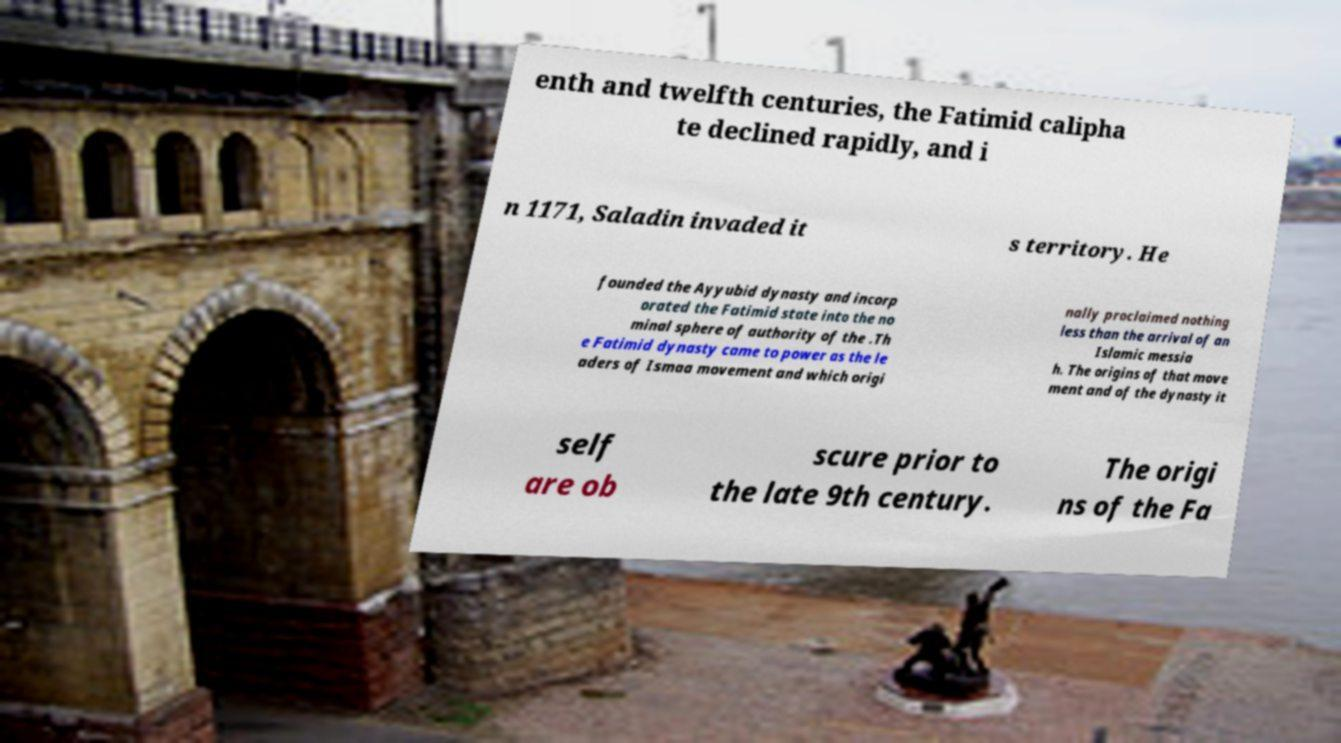Can you accurately transcribe the text from the provided image for me? enth and twelfth centuries, the Fatimid calipha te declined rapidly, and i n 1171, Saladin invaded it s territory. He founded the Ayyubid dynasty and incorp orated the Fatimid state into the no minal sphere of authority of the .Th e Fatimid dynasty came to power as the le aders of Ismaa movement and which origi nally proclaimed nothing less than the arrival of an Islamic messia h. The origins of that move ment and of the dynasty it self are ob scure prior to the late 9th century. The origi ns of the Fa 